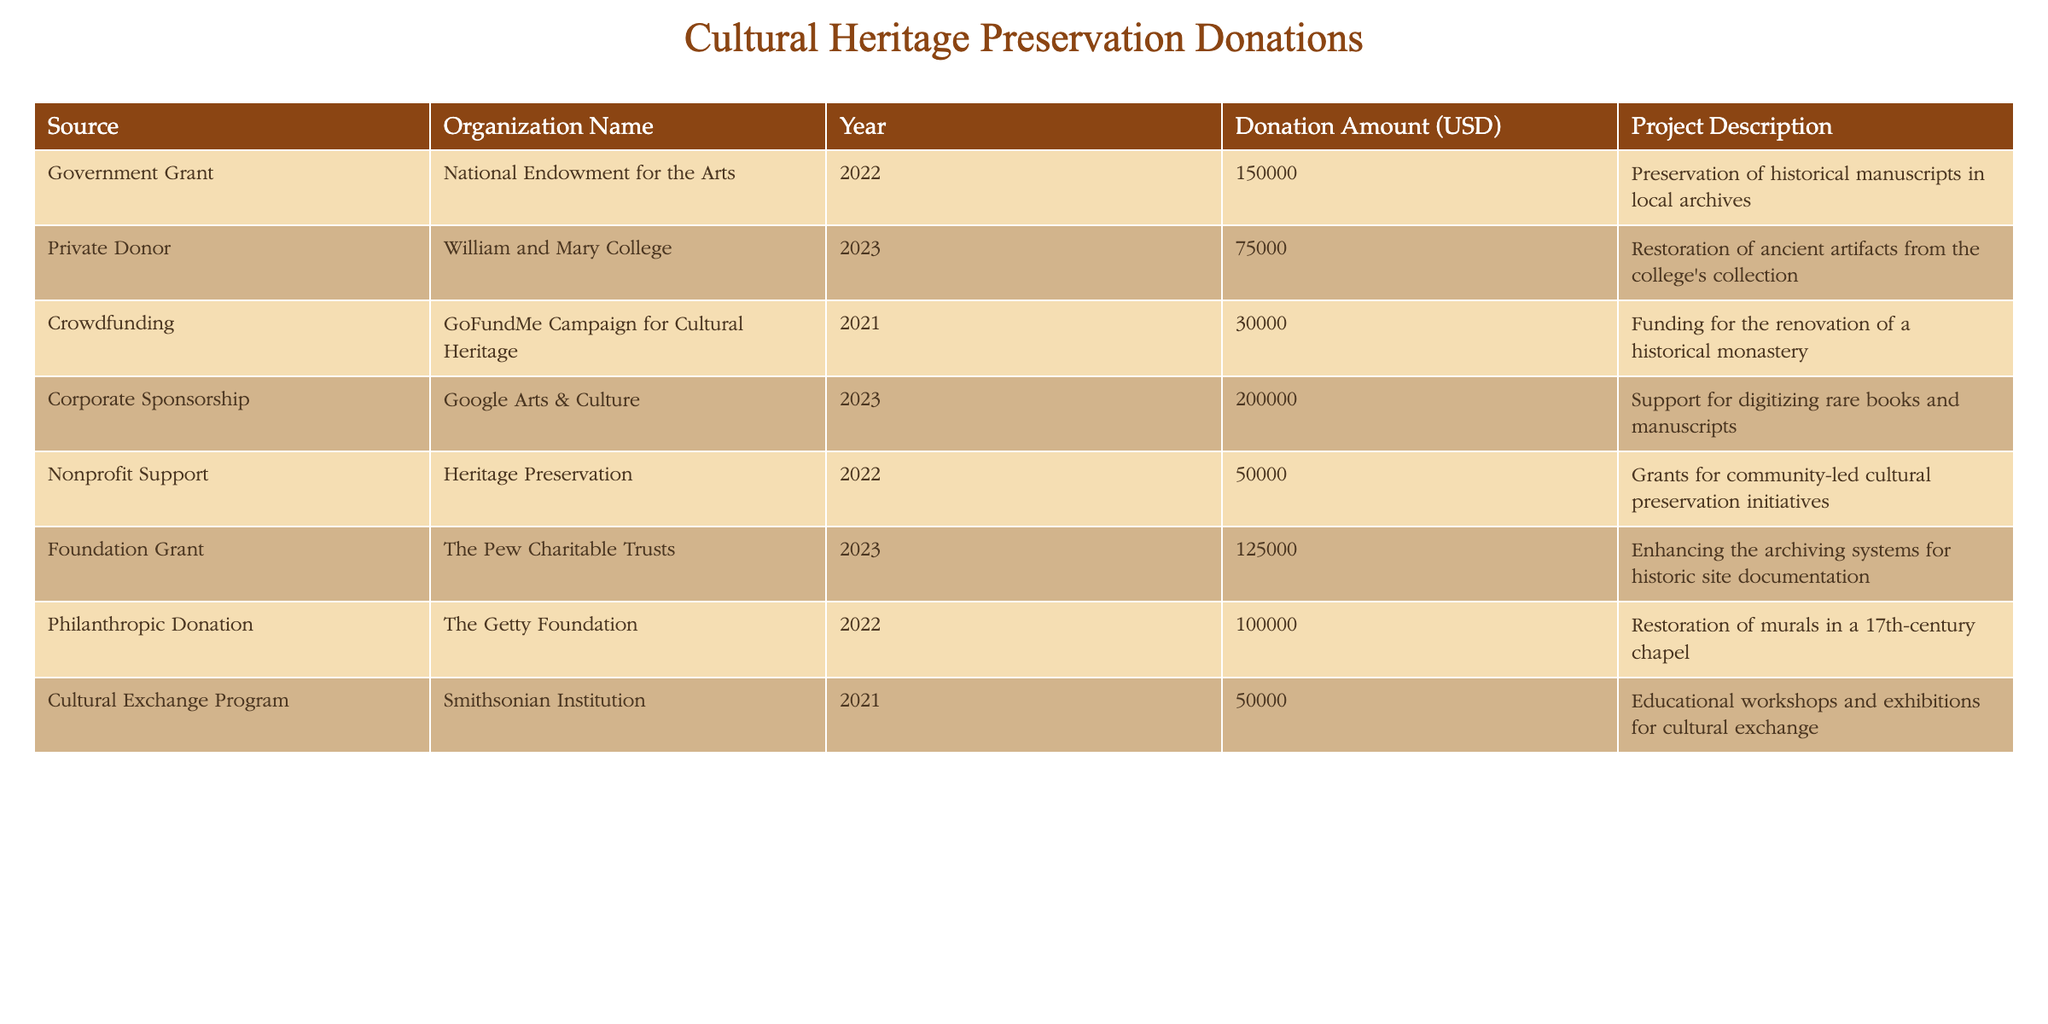What is the total amount donated from government grants? From the table, there is one government grant listed from the National Endowment for the Arts in 2022 with a donation amount of 150000 USD. Therefore, the total amount donated from government grants is simply this value.
Answer: 150000 USD Which organization contributed the largest donation and how much was it? Looking through the table, the largest donation comes from Google Arts & Culture in 2023, amounting to 200000 USD. This is the highest value in the Donation Amount column, indicating that it is the largest contribution.
Answer: Google Arts & Culture, 200000 USD How many donations were made for projects in 2023? The table shows two donations made in 2023: one from William and Mary College amounting to 75000 USD and another from Google Arts & Culture amounting to 200000 USD. Thus, there are two donations in total for that year.
Answer: 2 What is the average donation amount for the projects listed in the table? First, we need to sum all the donation amounts: 150000 + 75000 + 30000 + 200000 + 50000 + 125000 + 100000 + 50000 = 780000 USD. There are a total of 8 donations, so we divide the sum by the number of donations: 780000 / 8 = 97500 USD. Hence, the average donation amount is 97500 USD.
Answer: 97500 USD Is there a donation aimed at the restoration of a chapel? Yes, there is a donation for the restoration of murals in a 17th-century chapel provided by The Getty Foundation in 2022 for an amount of 100000 USD. This information can be confirmed by checking the Project Description column.
Answer: Yes Which type of donation (like government, private, etc.) has provided funding for cultural preservation initiatives in 2022? In 2022, there are two types of donations: one from the National Endowment for the Arts (Government Grant) for 150000 USD and another from Heritage Preservation (Nonprofit Support) for 50000 USD aimed at community-led cultural preservation initiatives. This confirms that both types contributed in that year.
Answer: Government Grant and Nonprofit Support What was the combined donation amount for projects related to cultural heritage in 2021? For 2021, donations include a crowdfunding campaign for 30000 USD and a donation from the Smithsonian Institution for 50000 USD. Adding these together gives 30000 + 50000 = 80000 USD. Therefore, the combined donation amount for that year is 80000 USD.
Answer: 80000 USD Were more donations made in the years 2022 or 2023? There were 4 donations made in 2022 (National Endowment for the Arts, Heritage Preservation, The Getty Foundation, and one more) and 3 in 2023 (William and Mary College, Google Arts & Culture, and The Pew Charitable Trusts). Therefore, we see that there are more donations in 2022 compared to 2023.
Answer: 2022 